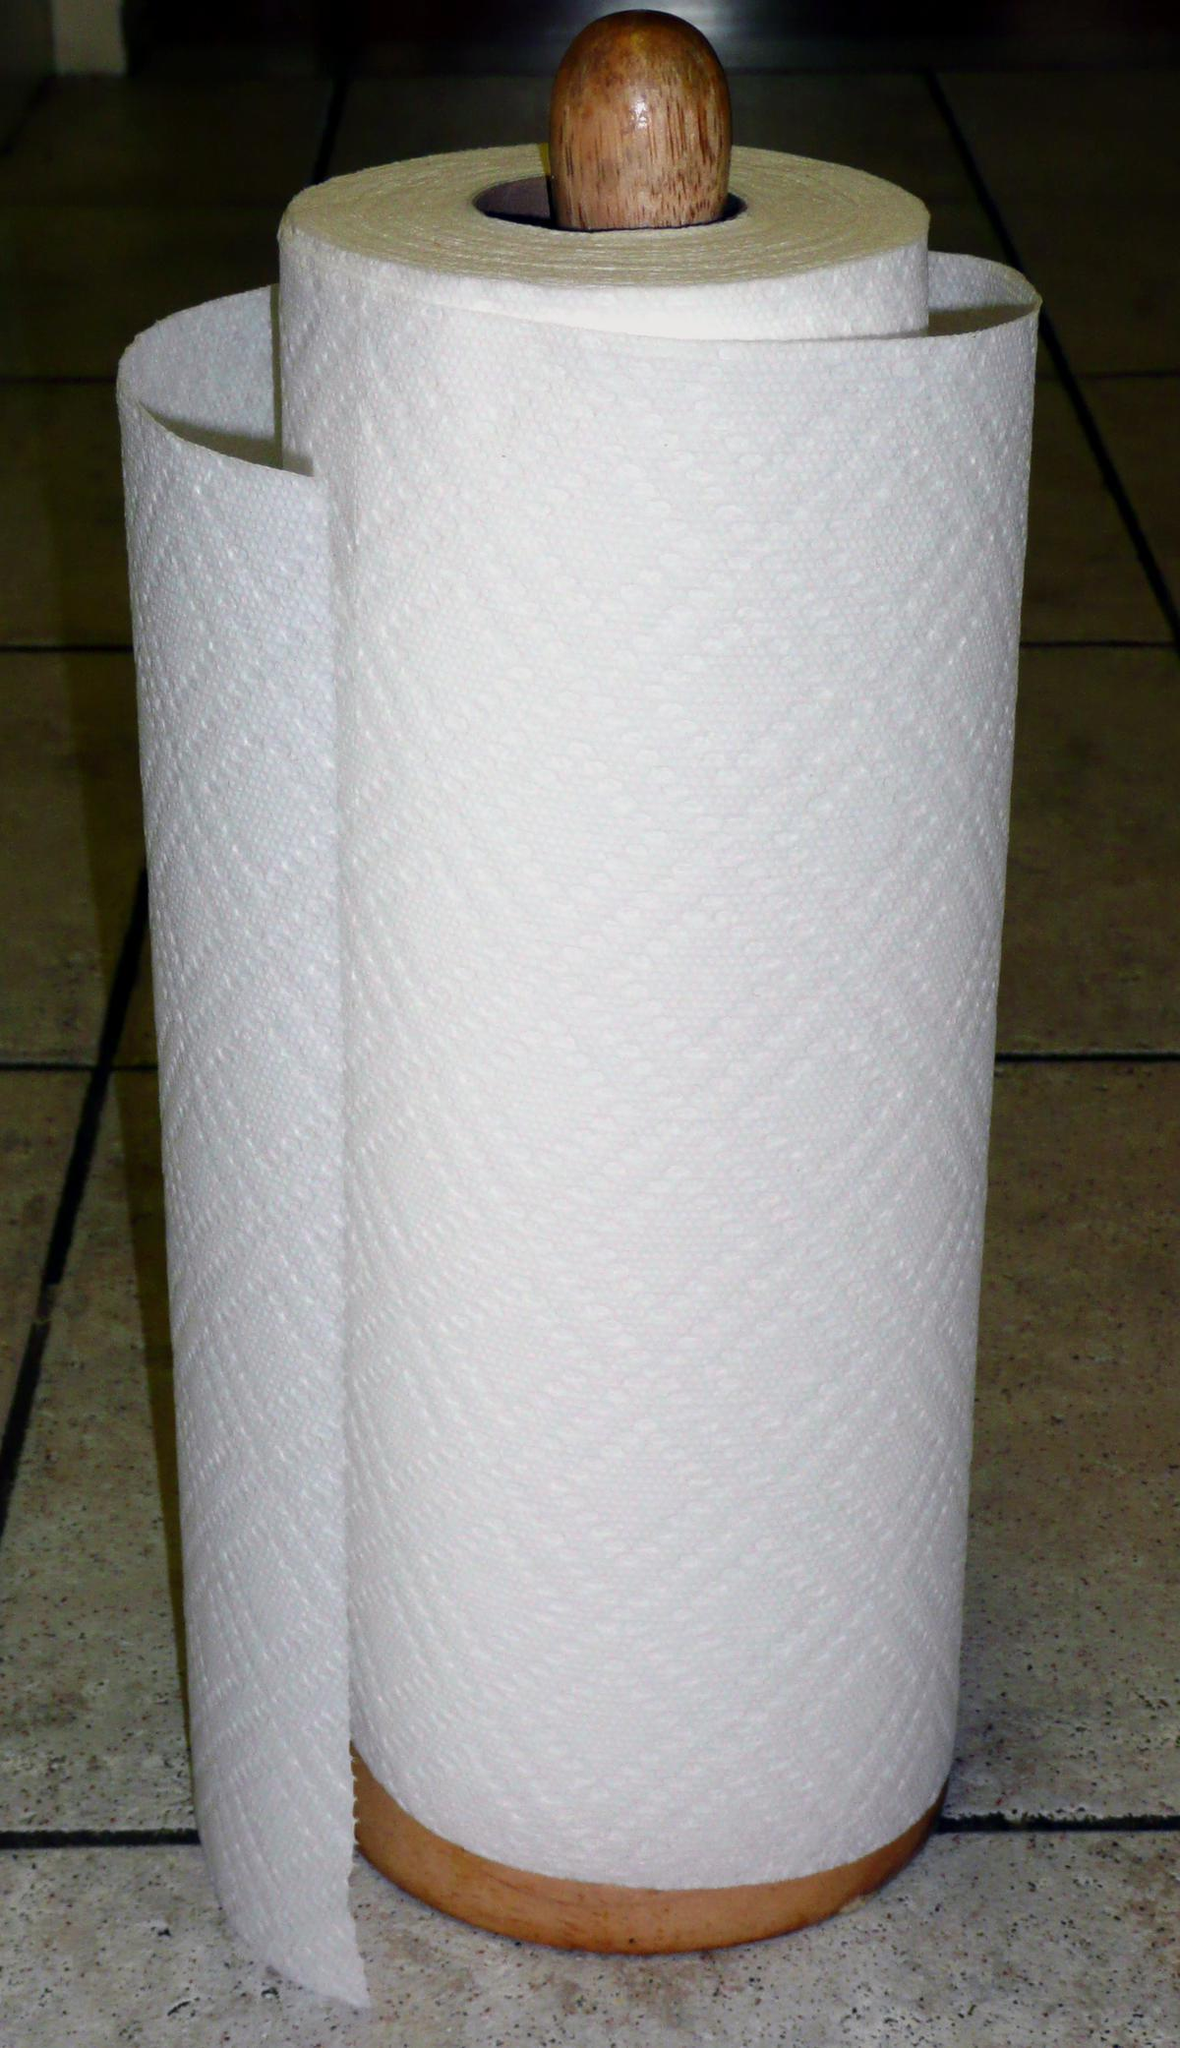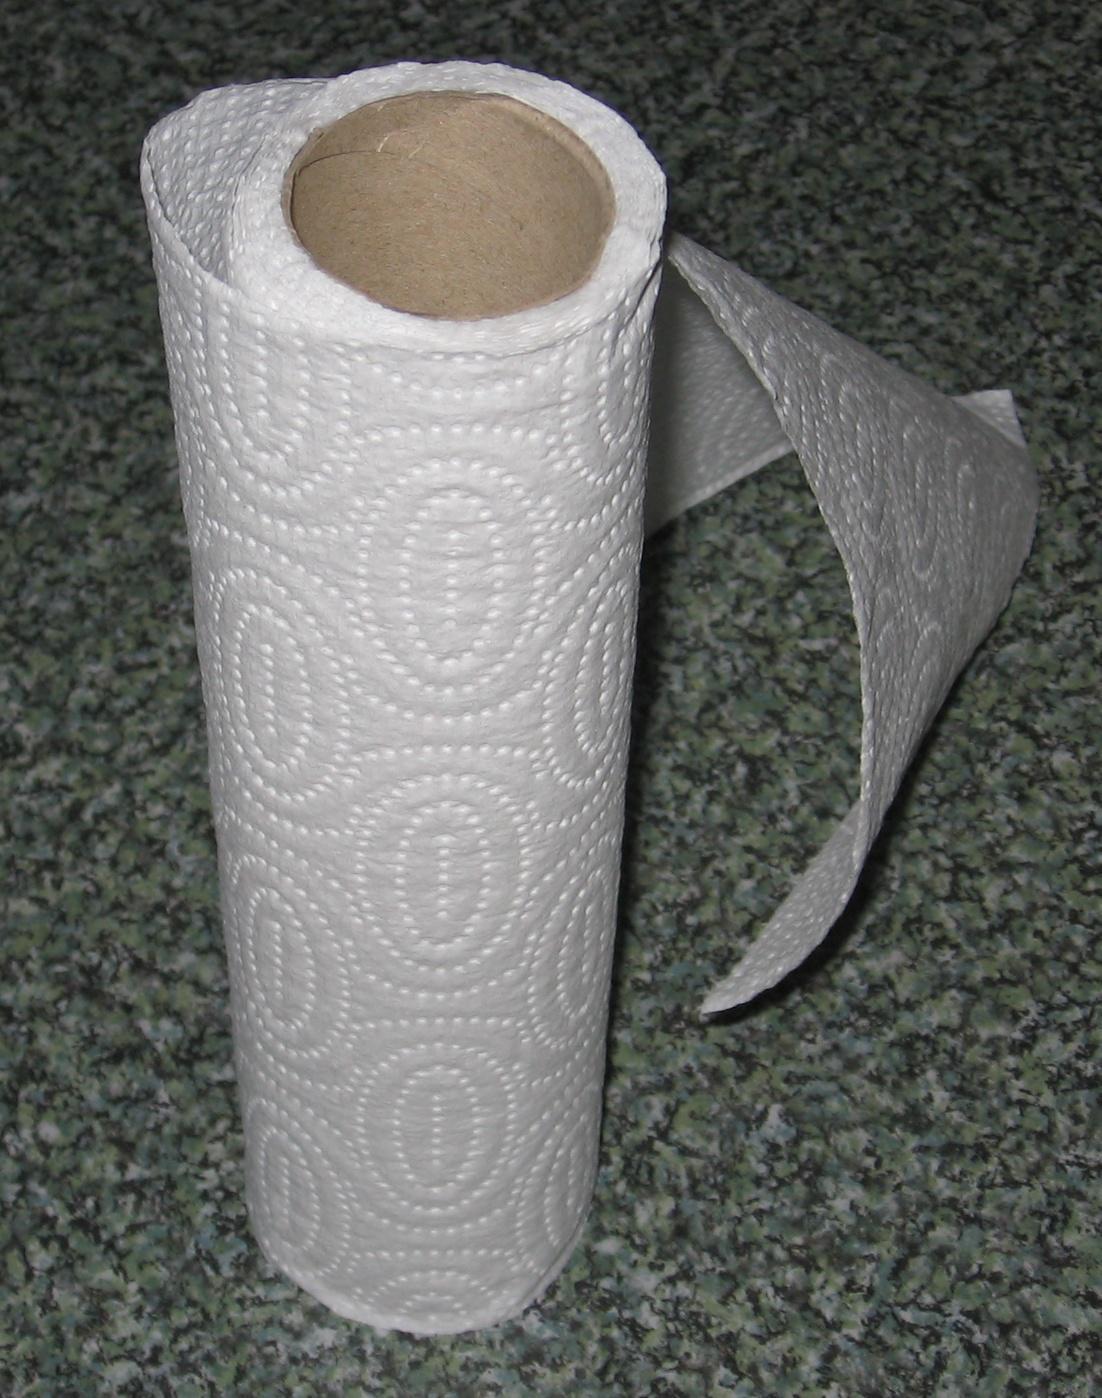The first image is the image on the left, the second image is the image on the right. Considering the images on both sides, is "Only one roll is shown on a stand holder." valid? Answer yes or no. Yes. 